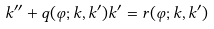Convert formula to latex. <formula><loc_0><loc_0><loc_500><loc_500>k ^ { \prime \prime } + q ( \varphi ; k , k ^ { \prime } ) k ^ { \prime } = r ( \varphi ; k , k ^ { \prime } )</formula> 